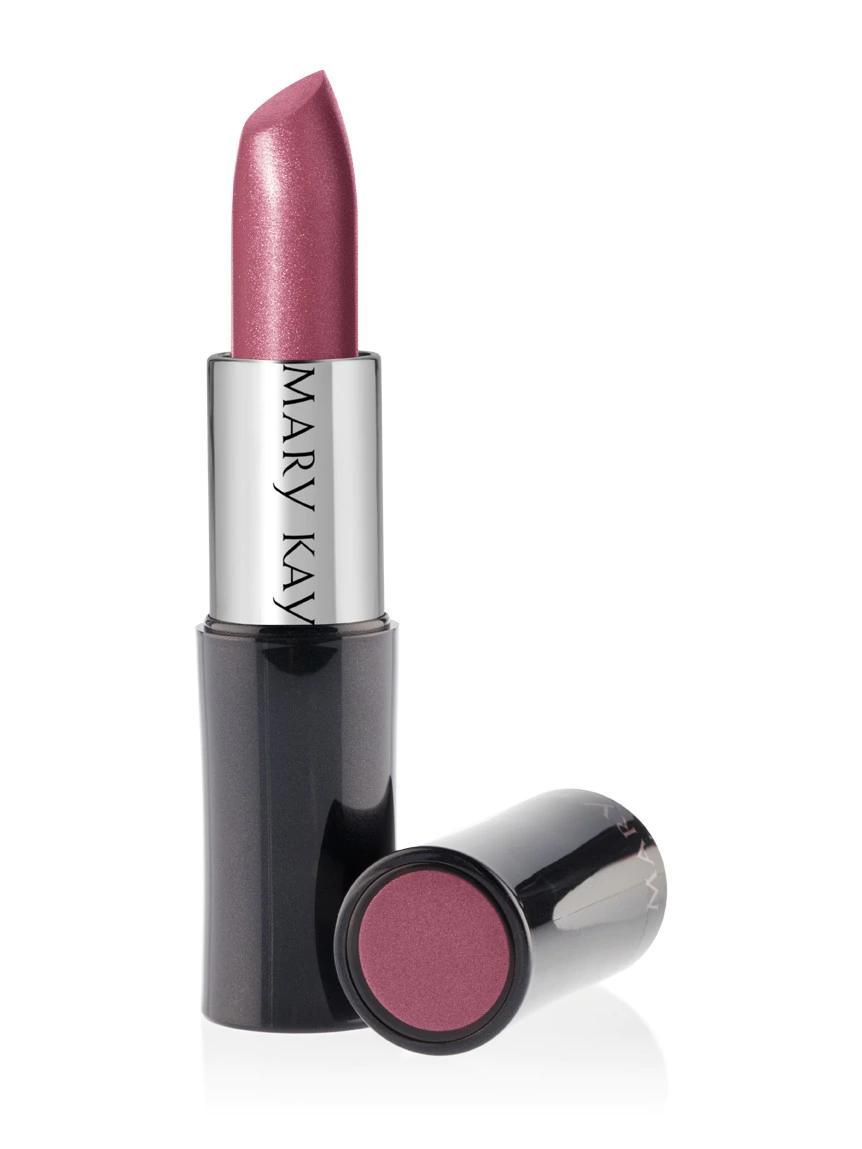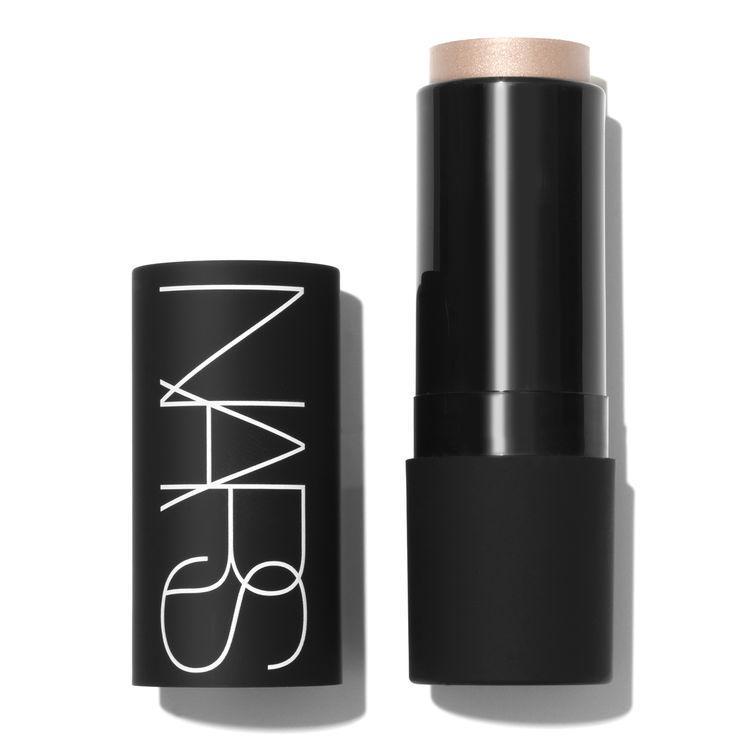The first image is the image on the left, the second image is the image on the right. For the images displayed, is the sentence "the left image has flat topped lipstick" factually correct? Answer yes or no. No. The first image is the image on the left, the second image is the image on the right. For the images shown, is this caption "The withdrawn lipstick tube in the left image has a flat top." true? Answer yes or no. No. 